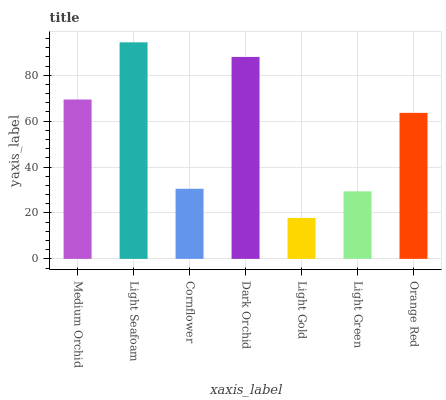Is Light Gold the minimum?
Answer yes or no. Yes. Is Light Seafoam the maximum?
Answer yes or no. Yes. Is Cornflower the minimum?
Answer yes or no. No. Is Cornflower the maximum?
Answer yes or no. No. Is Light Seafoam greater than Cornflower?
Answer yes or no. Yes. Is Cornflower less than Light Seafoam?
Answer yes or no. Yes. Is Cornflower greater than Light Seafoam?
Answer yes or no. No. Is Light Seafoam less than Cornflower?
Answer yes or no. No. Is Orange Red the high median?
Answer yes or no. Yes. Is Orange Red the low median?
Answer yes or no. Yes. Is Light Gold the high median?
Answer yes or no. No. Is Light Green the low median?
Answer yes or no. No. 